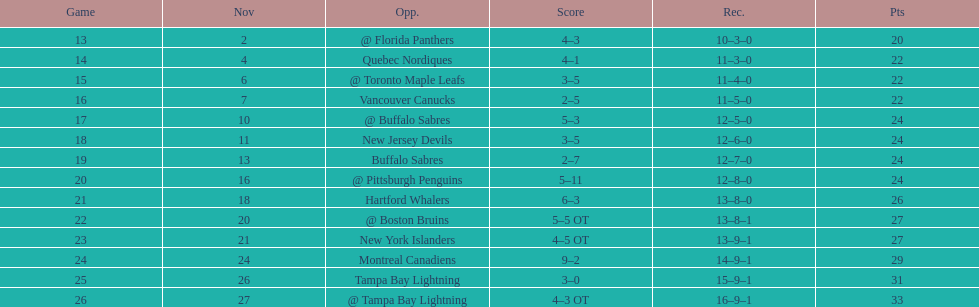Who had the most assists on the 1993-1994 flyers? Mark Recchi. 